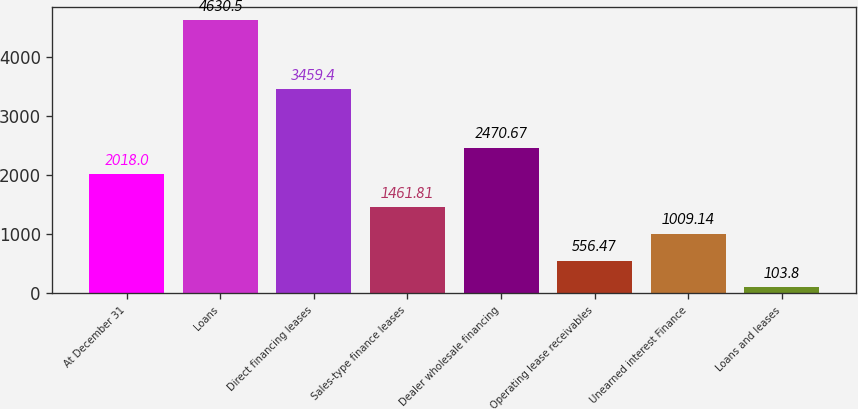Convert chart to OTSL. <chart><loc_0><loc_0><loc_500><loc_500><bar_chart><fcel>At December 31<fcel>Loans<fcel>Direct financing leases<fcel>Sales-type finance leases<fcel>Dealer wholesale financing<fcel>Operating lease receivables<fcel>Unearned interest Finance<fcel>Loans and leases<nl><fcel>2018<fcel>4630.5<fcel>3459.4<fcel>1461.81<fcel>2470.67<fcel>556.47<fcel>1009.14<fcel>103.8<nl></chart> 